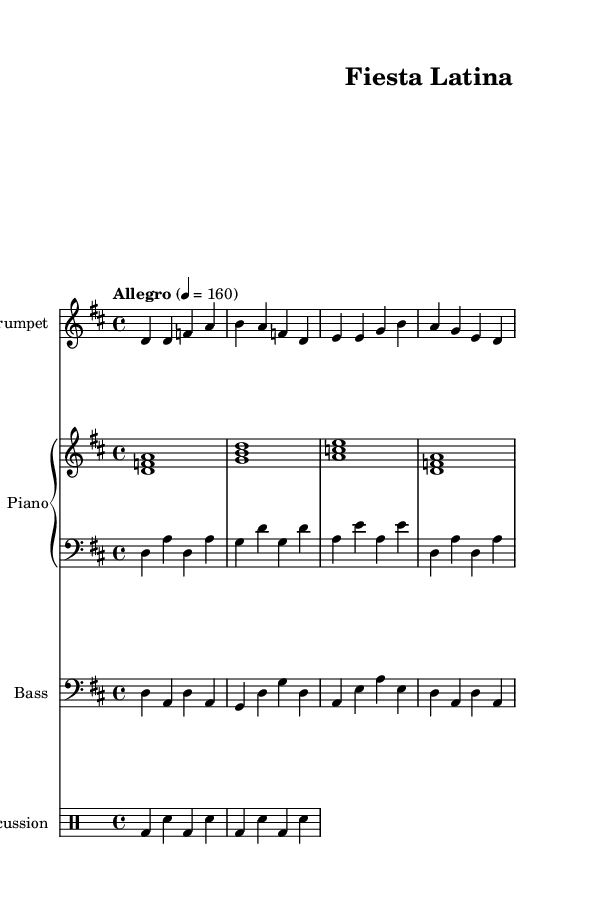What is the key signature of this music? The key signature indicates D major, which has two sharps (F# and C#). This can be identified by looking at the clef and the sharps present at the beginning of the staff.
Answer: D major What is the time signature of this music? The time signature displayed at the beginning of the piece is 4/4, which means there are four beats in each measure and the quarter note gets one beat. This can be seen next to the clef at the start of the music.
Answer: 4/4 What is the tempo marking of this music? The indicated tempo marking is "Allegro" with a metronome marking of 160 BPM, suggesting a fast and lively pace. This is explicitly noted in the tempo section at the beginning of the score.
Answer: Allegro 4 = 160 How many measures are in the trumpet melody? The trumpet melody consists of four measures, which can be counted by identifying the vertical bar lines in the notation that separate each measure.
Answer: 4 What type of rhythmic pattern is used in the percussion part? The percussion part features a standard pattern that alternates bass drum and snare hits. Analyzing the percussion notation shows the alternating bass drum and snare hits across measures.
Answer: Alternating Which instruments are present in this score? The score includes four distinct instruments: Trumpet, Piano (with right and left hand parts), Bass, and Percussion. Each instrument has its own staff in the score, identifiable by the instrument names listed.
Answer: Trumpet, Piano, Bass, Percussion What genre does this music represent? The music represents Latin music, specifically characterized by salsa and merengue styles, which is evident in its lively tempo and rhythmic structure, as well as the instrumentation typically used in these genres.
Answer: Latin 